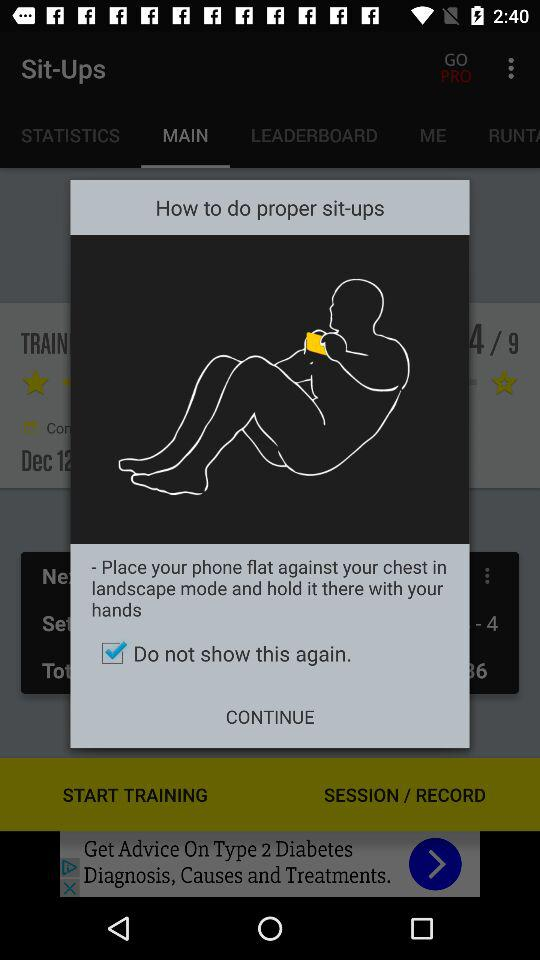What is the status of "Do not show this again"? The status is "on". 